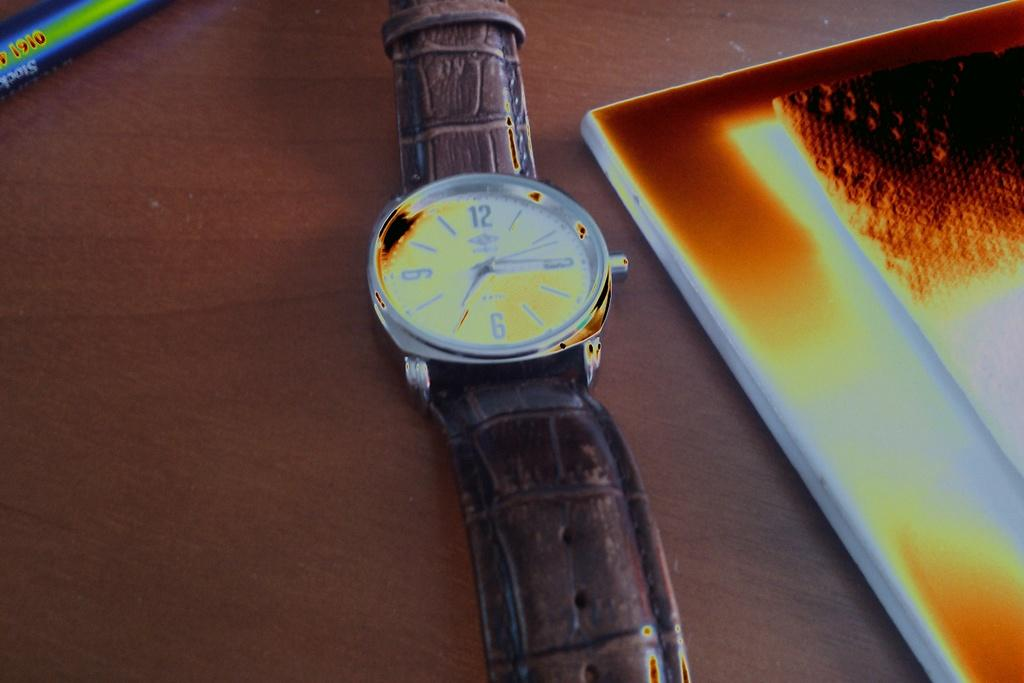<image>
Write a terse but informative summary of the picture. Watch on a table next to a book that says the year 1910. 